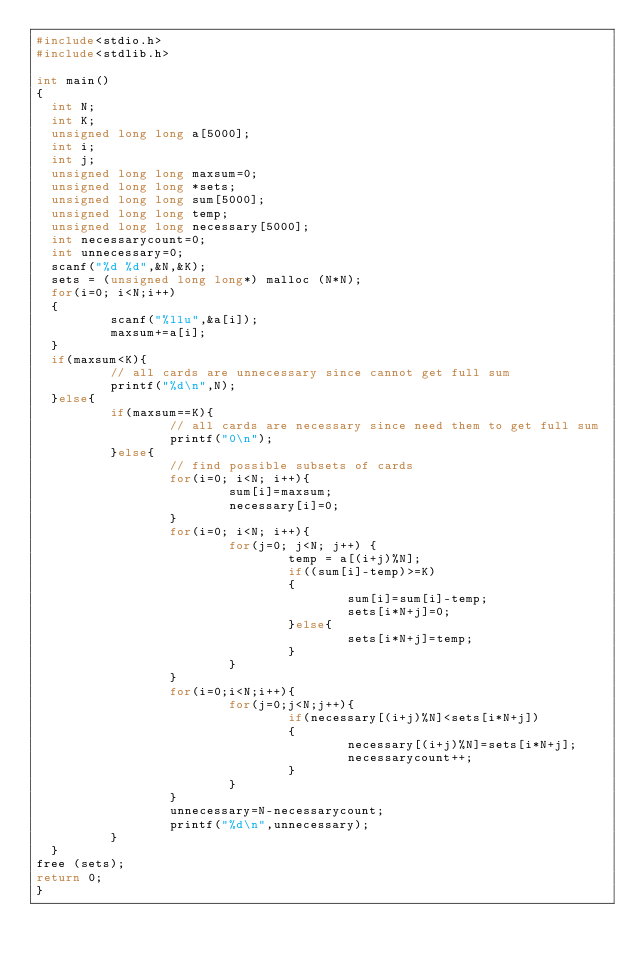<code> <loc_0><loc_0><loc_500><loc_500><_C_>#include<stdio.h>
#include<stdlib.h>

int main()
{
  int N;
  int K;
  unsigned long long a[5000];
  int i;
  int j;
  unsigned long long maxsum=0;
  unsigned long long *sets;
  unsigned long long sum[5000];
  unsigned long long temp;
  unsigned long long necessary[5000];
  int necessarycount=0;
  int unnecessary=0;
  scanf("%d %d",&N,&K);
  sets = (unsigned long long*) malloc (N*N);
  for(i=0; i<N;i++) 
  {
          scanf("%llu",&a[i]);
          maxsum+=a[i];
  }
  if(maxsum<K){  
          // all cards are unnecessary since cannot get full sum
          printf("%d\n",N);
  }else{
          if(maxsum==K){
                  // all cards are necessary since need them to get full sum
                  printf("0\n");
          }else{
                  // find possible subsets of cards
                  for(i=0; i<N; i++){
                          sum[i]=maxsum;
                          necessary[i]=0;
                  }
                  for(i=0; i<N; i++){
                          for(j=0; j<N; j++) {
                                  temp = a[(i+j)%N];
                                  if((sum[i]-temp)>=K)
                                  {
                                          sum[i]=sum[i]-temp;
                                          sets[i*N+j]=0;
                                  }else{
                                          sets[i*N+j]=temp;
                                  }
                          }
                  }
                  for(i=0;i<N;i++){
                          for(j=0;j<N;j++){
                                  if(necessary[(i+j)%N]<sets[i*N+j])
                                  {
                                          necessary[(i+j)%N]=sets[i*N+j];
                                          necessarycount++;
                                  }
                          }
                  }
                  unnecessary=N-necessarycount;
                  printf("%d\n",unnecessary);
          }
  }
free (sets);
return 0;
}</code> 